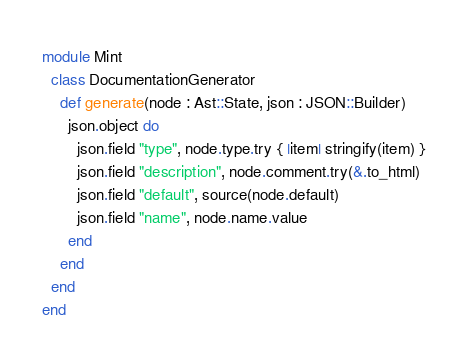<code> <loc_0><loc_0><loc_500><loc_500><_Crystal_>module Mint
  class DocumentationGenerator
    def generate(node : Ast::State, json : JSON::Builder)
      json.object do
        json.field "type", node.type.try { |item| stringify(item) }
        json.field "description", node.comment.try(&.to_html)
        json.field "default", source(node.default)
        json.field "name", node.name.value
      end
    end
  end
end
</code> 